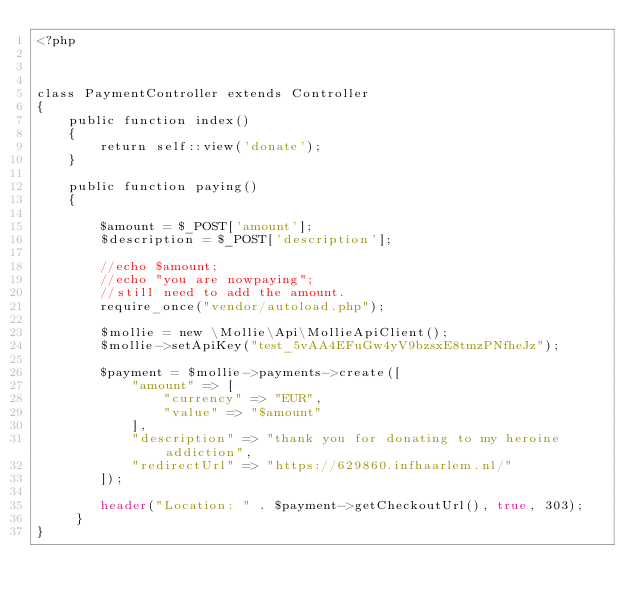<code> <loc_0><loc_0><loc_500><loc_500><_PHP_><?php



class PaymentController extends Controller
{
    public function index()
    {
        return self::view('donate');
    }

    public function paying()
    {

        $amount = $_POST['amount'];
        $description = $_POST['description'];

        //echo $amount;    
        //echo "you are nowpaying";
        //still need to add the amount.
        require_once("vendor/autoload.php");

        $mollie = new \Mollie\Api\MollieApiClient();
        $mollie->setApiKey("test_5vAA4EFuGw4yV9bzsxE8tmzPNfheJz");

        $payment = $mollie->payments->create([
            "amount" => [
                "currency" => "EUR",
                "value" => "$amount"
            ],
            "description" => "thank you for donating to my heroine addiction",
            "redirectUrl" => "https://629860.infhaarlem.nl/"
        ]);

        header("Location: " . $payment->getCheckoutUrl(), true, 303);
     }
}</code> 